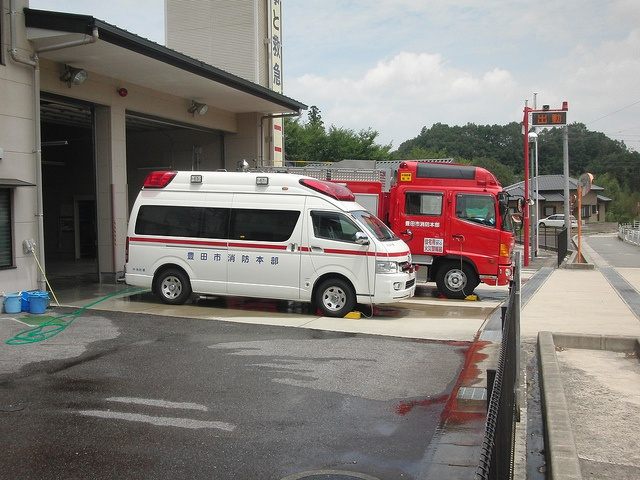Describe the objects in this image and their specific colors. I can see truck in black, brown, gray, and darkgray tones, traffic light in black, gray, brown, darkgray, and maroon tones, and car in black, darkgray, gray, and lightgray tones in this image. 